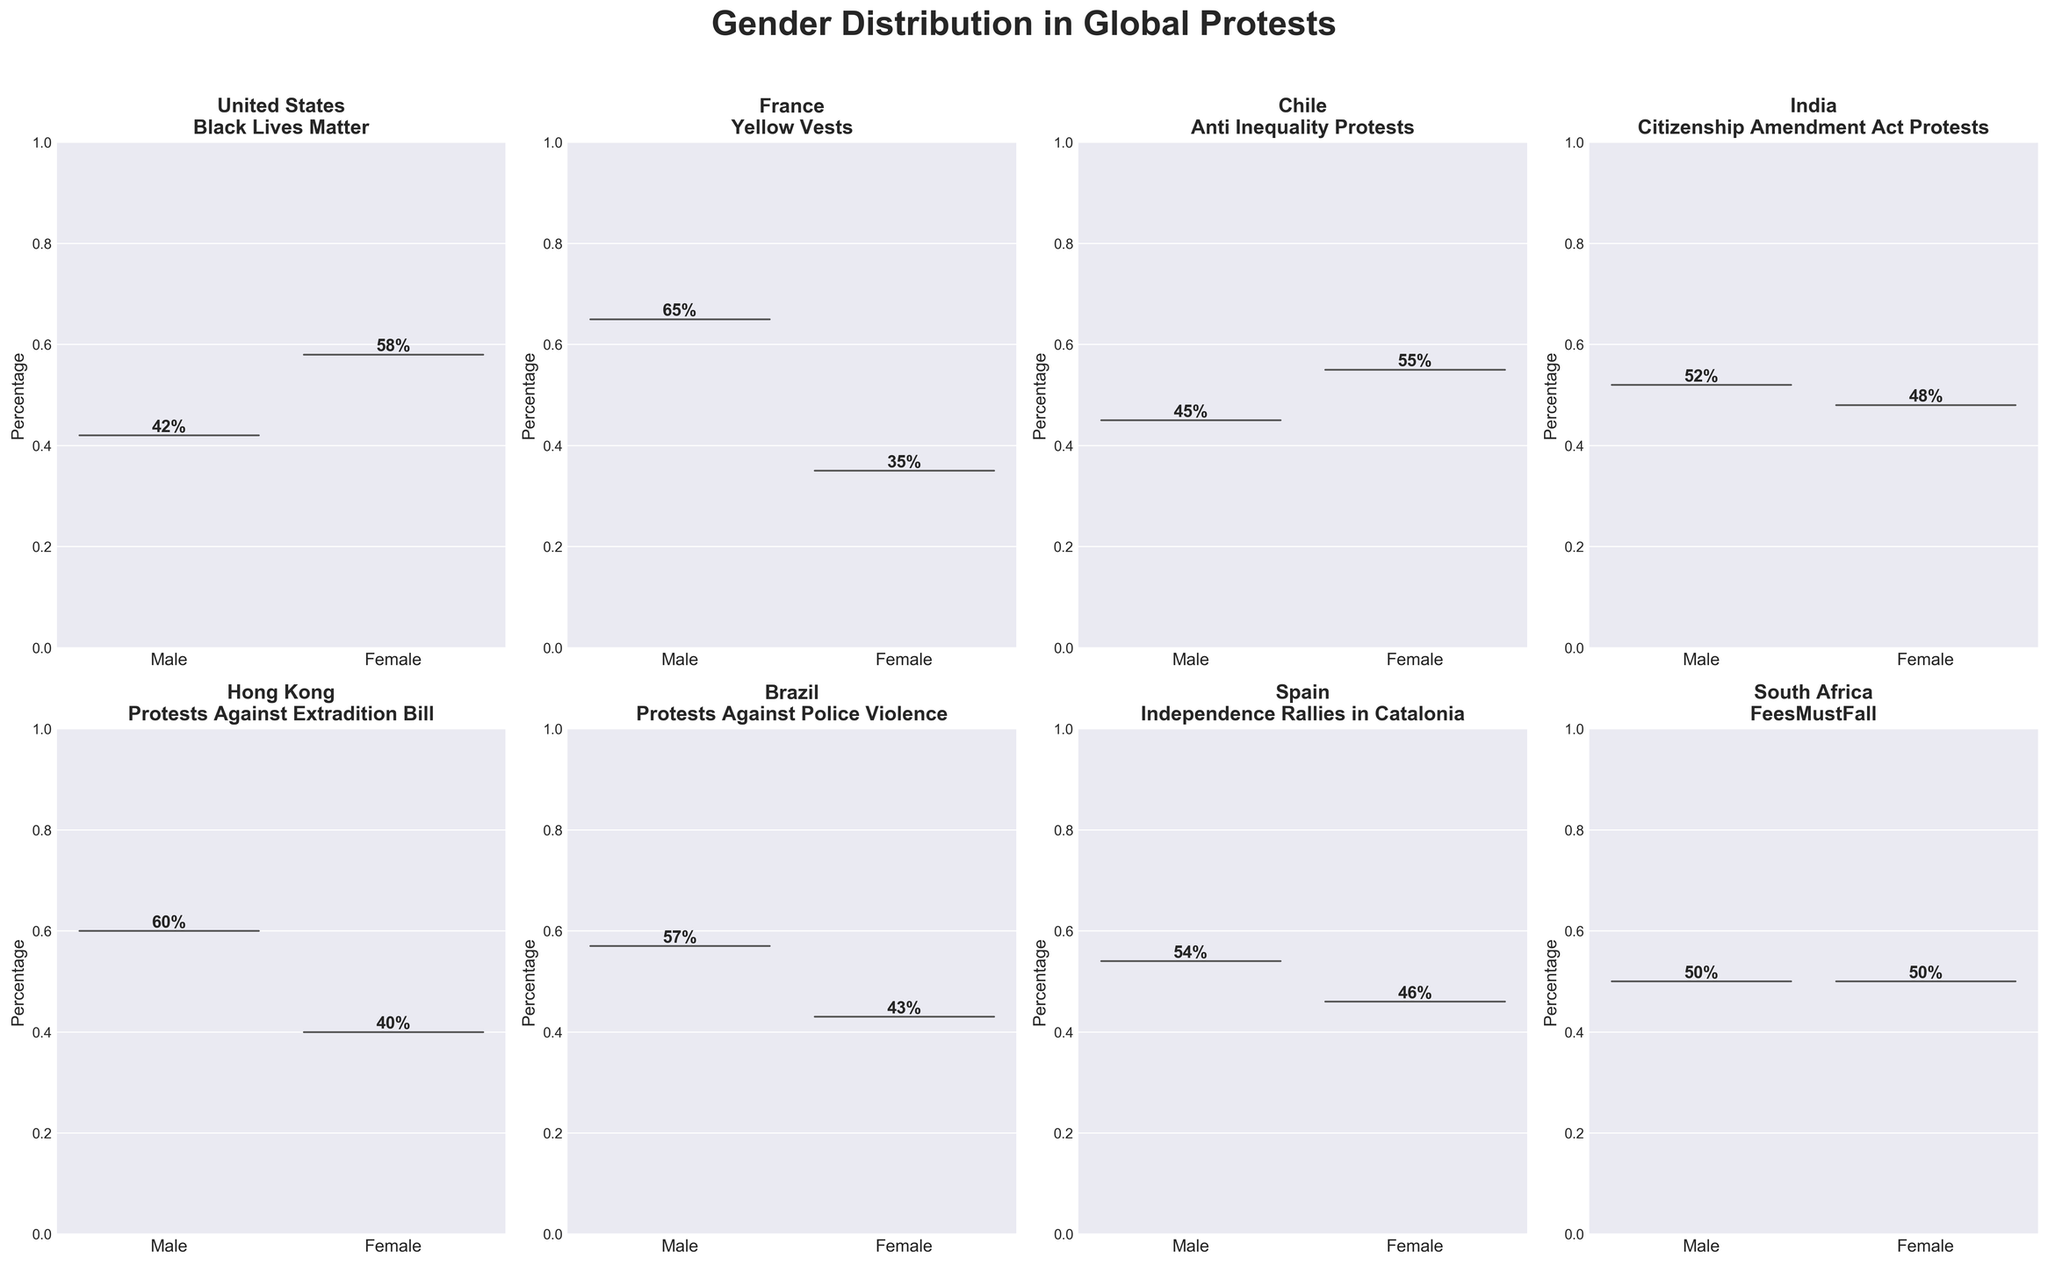What is the percentage of females in the Black Lives Matter protests in the United States? In the subplot for the United States, the female percentage value is given directly within the violin plot.
Answer: 58% Which country has the highest male participation percentage in its represented protest? By comparing the max values in the male distributions across all subplots, France's Yellow Vests protests have the highest male participation.
Answer: France Is female participation greater in Chile's Anti Inequality Protests or Brazil's Protests Against Police Violence? Chile's female participation is 55%, whereas Brazil's is 43%. Therefore, Chile has a higher female participation.
Answer: Chile Between Spain and South Africa, which country has a more balanced gender distribution in protests? In Spain, males are 54% and females are 46%. In South Africa, both genders participate equally at 50%. South Africa has a more balanced gender distribution.
Answer: South Africa How many countries have more male participation than female participation in their protests? By inspecting each subplot, United States, France, Hong Kong, Brazil, Spain, and India all have more or equal male participation. So, there are five countries with higher male participation.
Answer: 6 Which protest has the least gender imbalance? The subplot for South Africa shows both genders at 50%, indicating the least gender imbalance.
Answer: South Africa What is the title of the plot related to this data? The title is located above the subplots and reads "Gender Distribution in Global Protests."
Answer: Gender Distribution in Global Protests Compare the percentage difference between male and female participation in India's Citizenship Amendment Act Protests. Females participate at 48% and males at 52%. The difference is 52% - 48% = 4%.
Answer: 4% What is the average percentage of female participation across all protests? Adding the female percentages: 58%, 35%, 55%, 48%, 40%, 43%, 46%, 50% and averaging them: (58 + 35 + 55 + 48 + 40 + 43 + 46 + 50) / 8 = 46.875%.
Answer: 46.875% Which protests have a gender distribution closest to 50/50? By examining the equal distributions within the figure, South Africa's FeesMustFall protests have a 50/50 gender distribution.
Answer: South Africa 